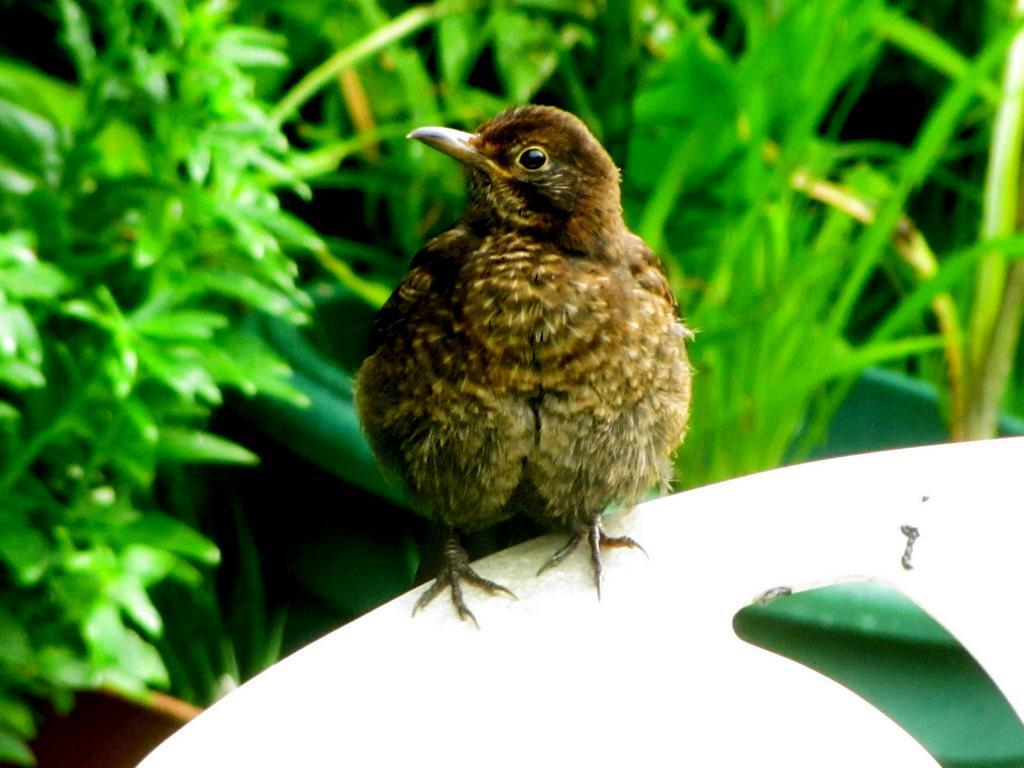What is the main subject in the foreground of the image? There is a bird in the foreground of the image. What is the bird doing in the image? The bird is sitting on an object. What can be seen in the background of the image? There are houseplants in the background of the image. Can you tell if the image was taken during the day or night? The image was likely taken during the day, as there is no indication of darkness or artificial lighting. What type of behavior is the bird exhibiting during the meeting with its daughter in the image? There is no meeting or daughter present in the image; it features a bird sitting on an object with houseplants in the background. 